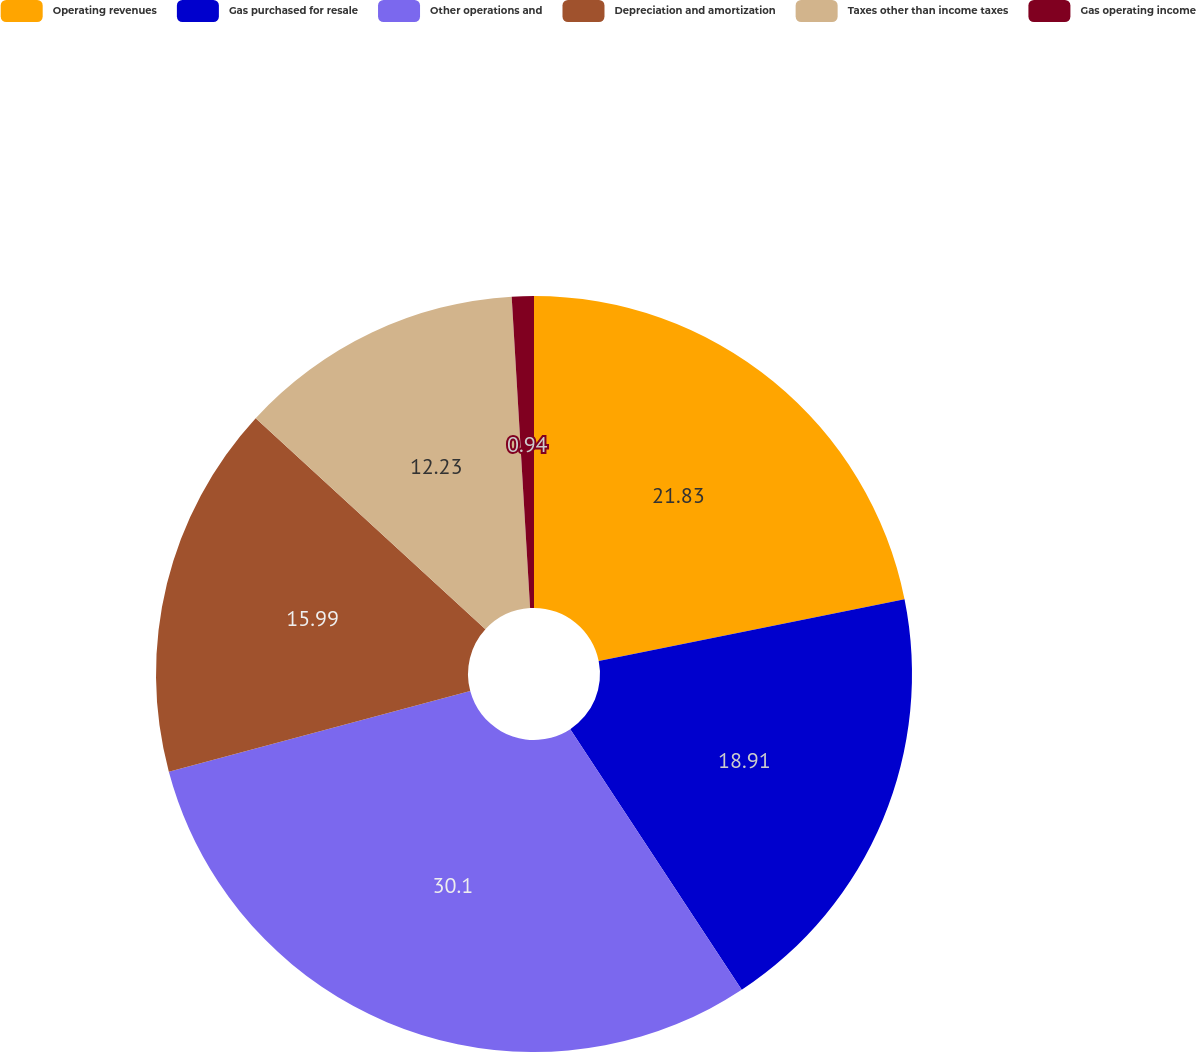Convert chart to OTSL. <chart><loc_0><loc_0><loc_500><loc_500><pie_chart><fcel>Operating revenues<fcel>Gas purchased for resale<fcel>Other operations and<fcel>Depreciation and amortization<fcel>Taxes other than income taxes<fcel>Gas operating income<nl><fcel>21.83%<fcel>18.91%<fcel>30.1%<fcel>15.99%<fcel>12.23%<fcel>0.94%<nl></chart> 